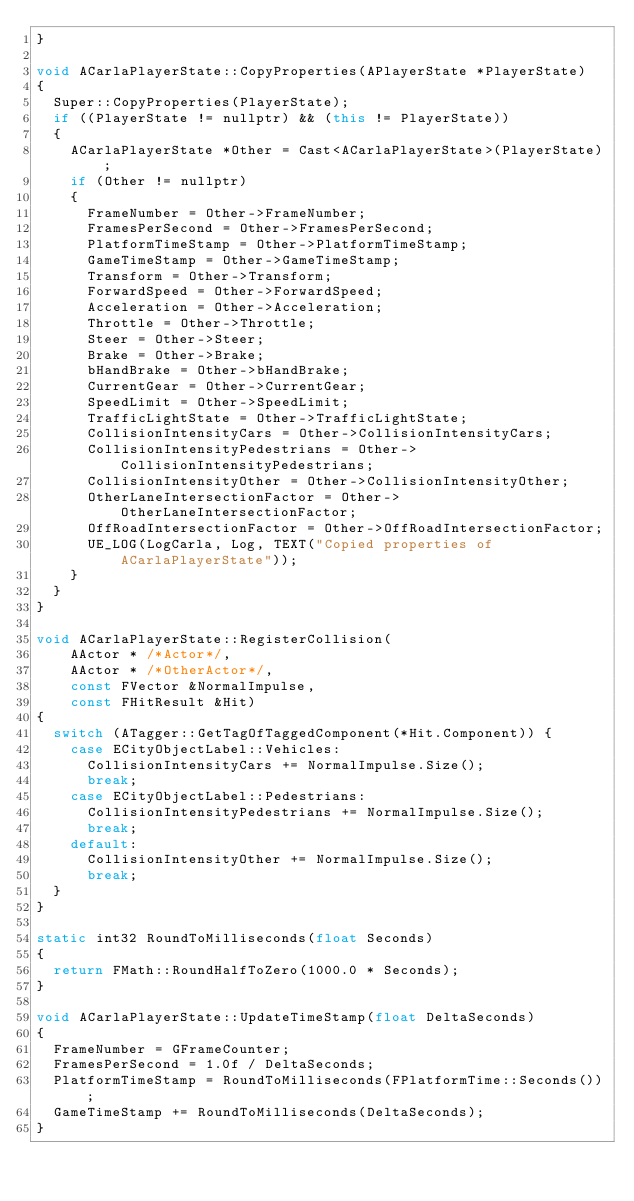Convert code to text. <code><loc_0><loc_0><loc_500><loc_500><_C++_>}

void ACarlaPlayerState::CopyProperties(APlayerState *PlayerState)
{
  Super::CopyProperties(PlayerState);
  if ((PlayerState != nullptr) && (this != PlayerState))
  {
    ACarlaPlayerState *Other = Cast<ACarlaPlayerState>(PlayerState);
    if (Other != nullptr)
    {
      FrameNumber = Other->FrameNumber;
      FramesPerSecond = Other->FramesPerSecond;
      PlatformTimeStamp = Other->PlatformTimeStamp;
      GameTimeStamp = Other->GameTimeStamp;
      Transform = Other->Transform;
      ForwardSpeed = Other->ForwardSpeed;
      Acceleration = Other->Acceleration;
      Throttle = Other->Throttle;
      Steer = Other->Steer;
      Brake = Other->Brake;
      bHandBrake = Other->bHandBrake;
      CurrentGear = Other->CurrentGear;
      SpeedLimit = Other->SpeedLimit;
      TrafficLightState = Other->TrafficLightState;
      CollisionIntensityCars = Other->CollisionIntensityCars;
      CollisionIntensityPedestrians = Other->CollisionIntensityPedestrians;
      CollisionIntensityOther = Other->CollisionIntensityOther;
      OtherLaneIntersectionFactor = Other->OtherLaneIntersectionFactor;
      OffRoadIntersectionFactor = Other->OffRoadIntersectionFactor;
      UE_LOG(LogCarla, Log, TEXT("Copied properties of ACarlaPlayerState"));
    }
  }
}

void ACarlaPlayerState::RegisterCollision(
    AActor * /*Actor*/,
    AActor * /*OtherActor*/,
    const FVector &NormalImpulse,
    const FHitResult &Hit)
{
  switch (ATagger::GetTagOfTaggedComponent(*Hit.Component)) {
    case ECityObjectLabel::Vehicles:
      CollisionIntensityCars += NormalImpulse.Size();
      break;
    case ECityObjectLabel::Pedestrians:
      CollisionIntensityPedestrians += NormalImpulse.Size();
      break;
    default:
      CollisionIntensityOther += NormalImpulse.Size();
      break;
  }
}

static int32 RoundToMilliseconds(float Seconds)
{
  return FMath::RoundHalfToZero(1000.0 * Seconds);
}

void ACarlaPlayerState::UpdateTimeStamp(float DeltaSeconds)
{
  FrameNumber = GFrameCounter;
  FramesPerSecond = 1.0f / DeltaSeconds;
  PlatformTimeStamp = RoundToMilliseconds(FPlatformTime::Seconds());
  GameTimeStamp += RoundToMilliseconds(DeltaSeconds);
}
</code> 